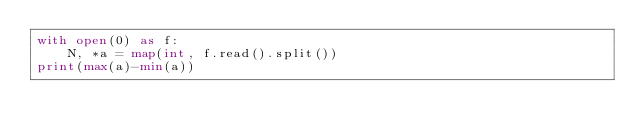<code> <loc_0><loc_0><loc_500><loc_500><_Python_>with open(0) as f:
    N, *a = map(int, f.read().split())
print(max(a)-min(a))</code> 